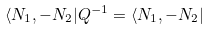<formula> <loc_0><loc_0><loc_500><loc_500>\langle N _ { 1 } , - N _ { 2 } | Q ^ { - 1 } = \langle N _ { 1 } , - N _ { 2 } |</formula> 